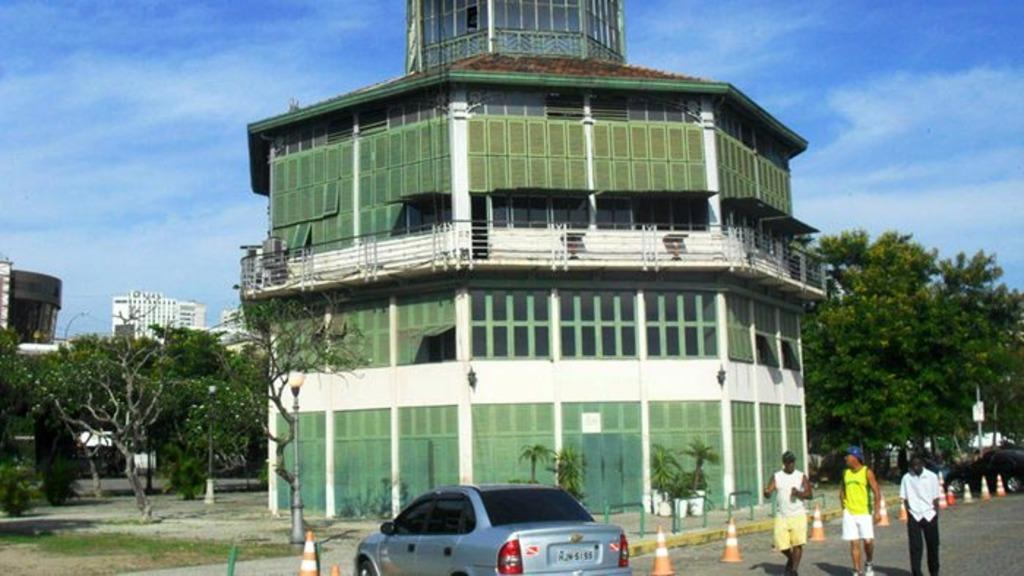Please provide a concise description of this image. In this picture I can observe green color building in the middle of the picture. On the right side I can observe three members walking on the road and there are traffic cones on the side of the road. In the bottom of the picture I can observe a car. In the background there are trees and sky. 